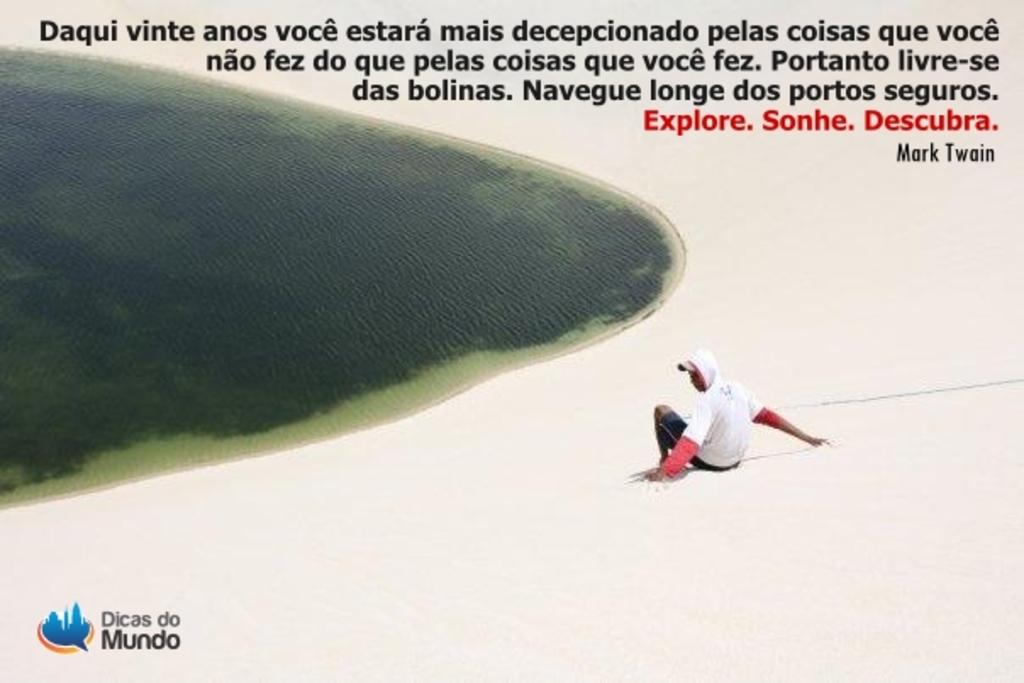<image>
Offer a succinct explanation of the picture presented. An advertisement displays the phrase Dicas do Mundo in the corner. 